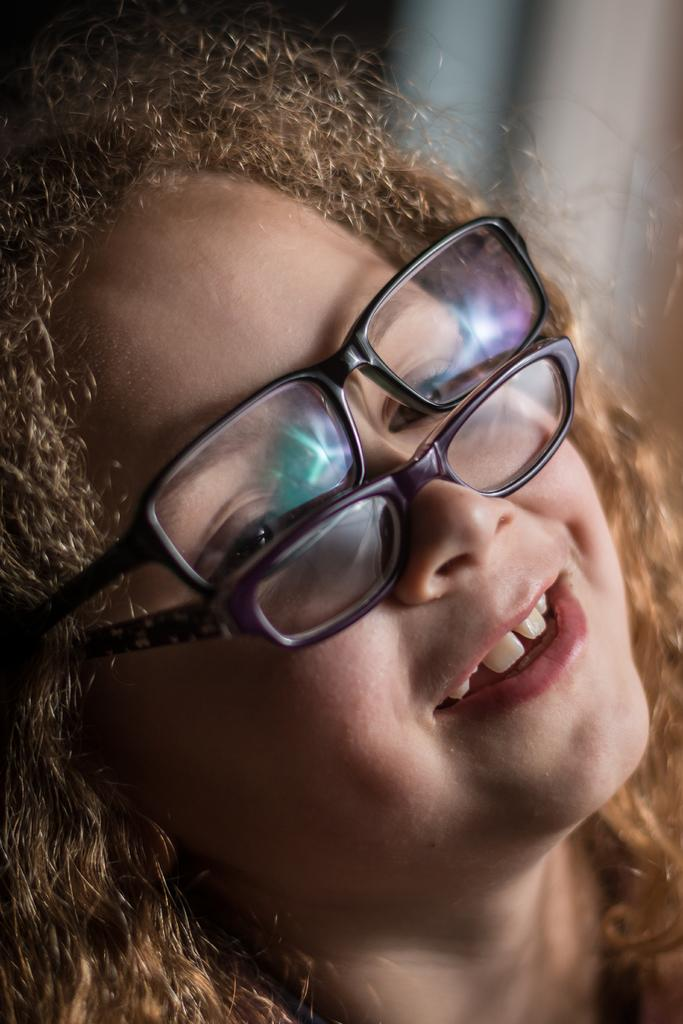What can be observed about the background of the image? The background of the picture is blurred. Who is the main subject in the image? There is a girl in the image. Can you describe the girl's hair? The girl has curly hair. What is the girl wearing on her face? The girl is wearing two pairs of spectacles. What is the girl's facial expression? The girl is smiling. What type of muscle is visible on the girl's arm in the image? There is no muscle visible on the girl's arm in the image. How does the girl react to the rainstorm in the image? There is no rainstorm present in the image, so the girl's reaction cannot be determined. 